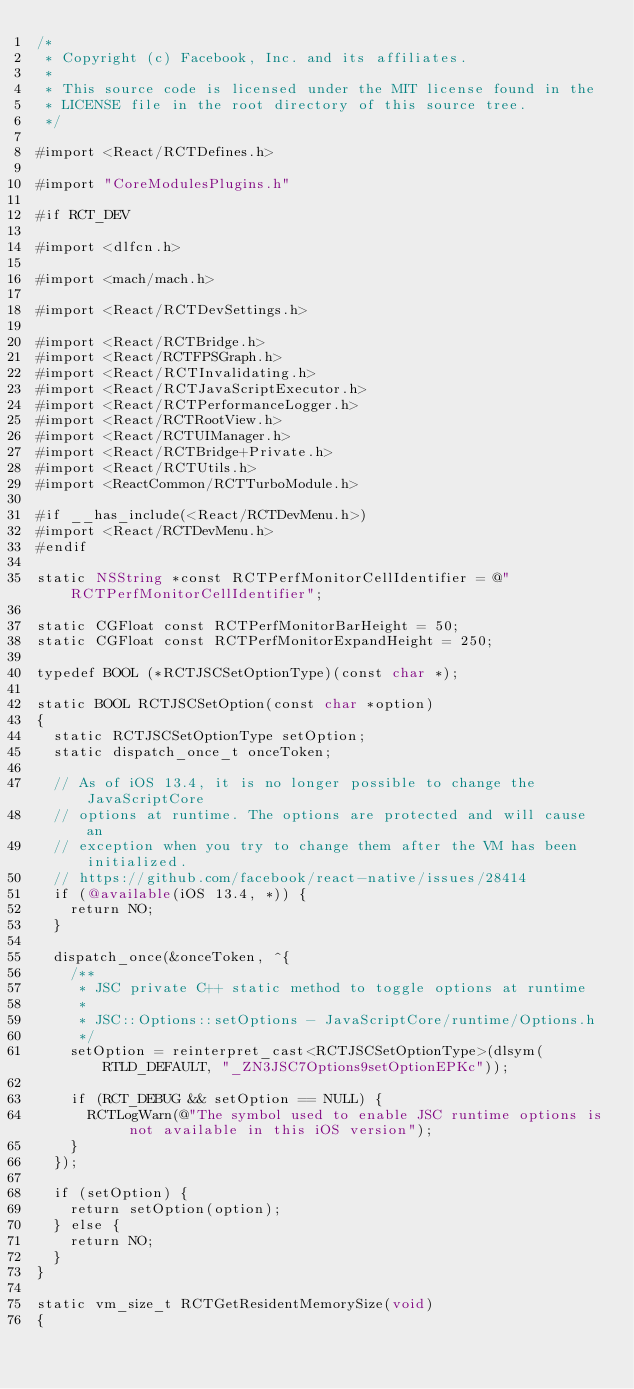<code> <loc_0><loc_0><loc_500><loc_500><_ObjectiveC_>/*
 * Copyright (c) Facebook, Inc. and its affiliates.
 *
 * This source code is licensed under the MIT license found in the
 * LICENSE file in the root directory of this source tree.
 */

#import <React/RCTDefines.h>

#import "CoreModulesPlugins.h"

#if RCT_DEV

#import <dlfcn.h>

#import <mach/mach.h>

#import <React/RCTDevSettings.h>

#import <React/RCTBridge.h>
#import <React/RCTFPSGraph.h>
#import <React/RCTInvalidating.h>
#import <React/RCTJavaScriptExecutor.h>
#import <React/RCTPerformanceLogger.h>
#import <React/RCTRootView.h>
#import <React/RCTUIManager.h>
#import <React/RCTBridge+Private.h>
#import <React/RCTUtils.h>
#import <ReactCommon/RCTTurboModule.h>

#if __has_include(<React/RCTDevMenu.h>)
#import <React/RCTDevMenu.h>
#endif

static NSString *const RCTPerfMonitorCellIdentifier = @"RCTPerfMonitorCellIdentifier";

static CGFloat const RCTPerfMonitorBarHeight = 50;
static CGFloat const RCTPerfMonitorExpandHeight = 250;

typedef BOOL (*RCTJSCSetOptionType)(const char *);

static BOOL RCTJSCSetOption(const char *option)
{
  static RCTJSCSetOptionType setOption;
  static dispatch_once_t onceToken;

  // As of iOS 13.4, it is no longer possible to change the JavaScriptCore
  // options at runtime. The options are protected and will cause an
  // exception when you try to change them after the VM has been initialized.
  // https://github.com/facebook/react-native/issues/28414
  if (@available(iOS 13.4, *)) {
    return NO;
  }

  dispatch_once(&onceToken, ^{
    /**
     * JSC private C++ static method to toggle options at runtime
     *
     * JSC::Options::setOptions - JavaScriptCore/runtime/Options.h
     */
    setOption = reinterpret_cast<RCTJSCSetOptionType>(dlsym(RTLD_DEFAULT, "_ZN3JSC7Options9setOptionEPKc"));

    if (RCT_DEBUG && setOption == NULL) {
      RCTLogWarn(@"The symbol used to enable JSC runtime options is not available in this iOS version");
    }
  });

  if (setOption) {
    return setOption(option);
  } else {
    return NO;
  }
}

static vm_size_t RCTGetResidentMemorySize(void)
{</code> 